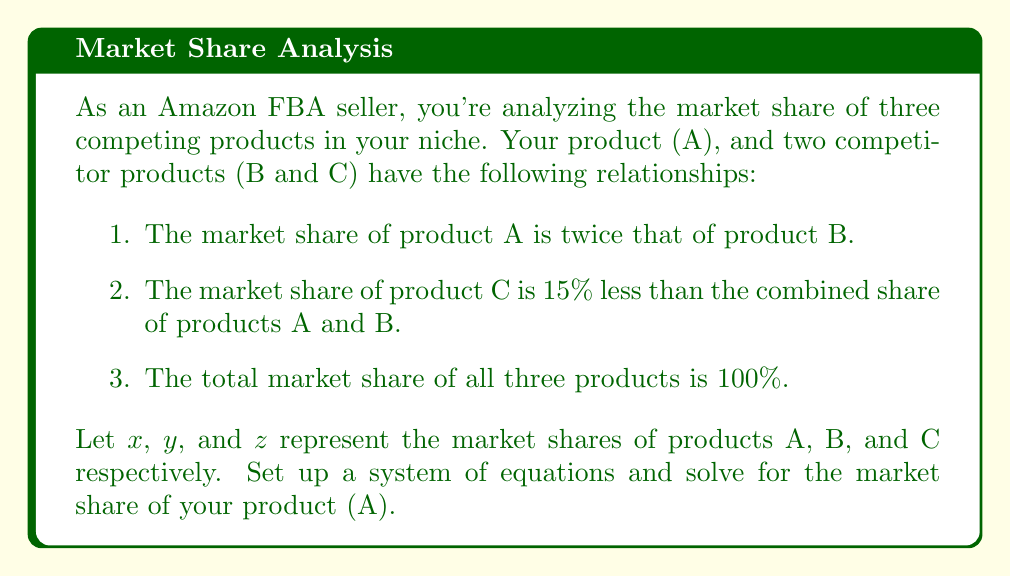Show me your answer to this math problem. Let's approach this step-by-step:

1. Translate the given information into equations:
   
   a. $x = 2y$ (A's share is twice B's)
   b. $z = 0.85(x + y)$ (C's share is 85% of A and B combined)
   c. $x + y + z = 100$ (Total market share is 100%)

2. Substitute the first equation into the second:
   
   $z = 0.85(2y + y) = 0.85(3y) = 2.55y$

3. Now we have three variables expressed in terms of $y$:
   
   $x = 2y$
   $z = 2.55y$

4. Substitute these into the third equation:
   
   $2y + y + 2.55y = 100$
   $5.55y = 100$

5. Solve for $y$:
   
   $y = 100 / 5.55 \approx 18.02$

6. Now we can find $x$ (the market share of product A):
   
   $x = 2y = 2(18.02) \approx 36.04$

Therefore, the market share of your product (A) is approximately 36.04%.
Answer: 36.04% 